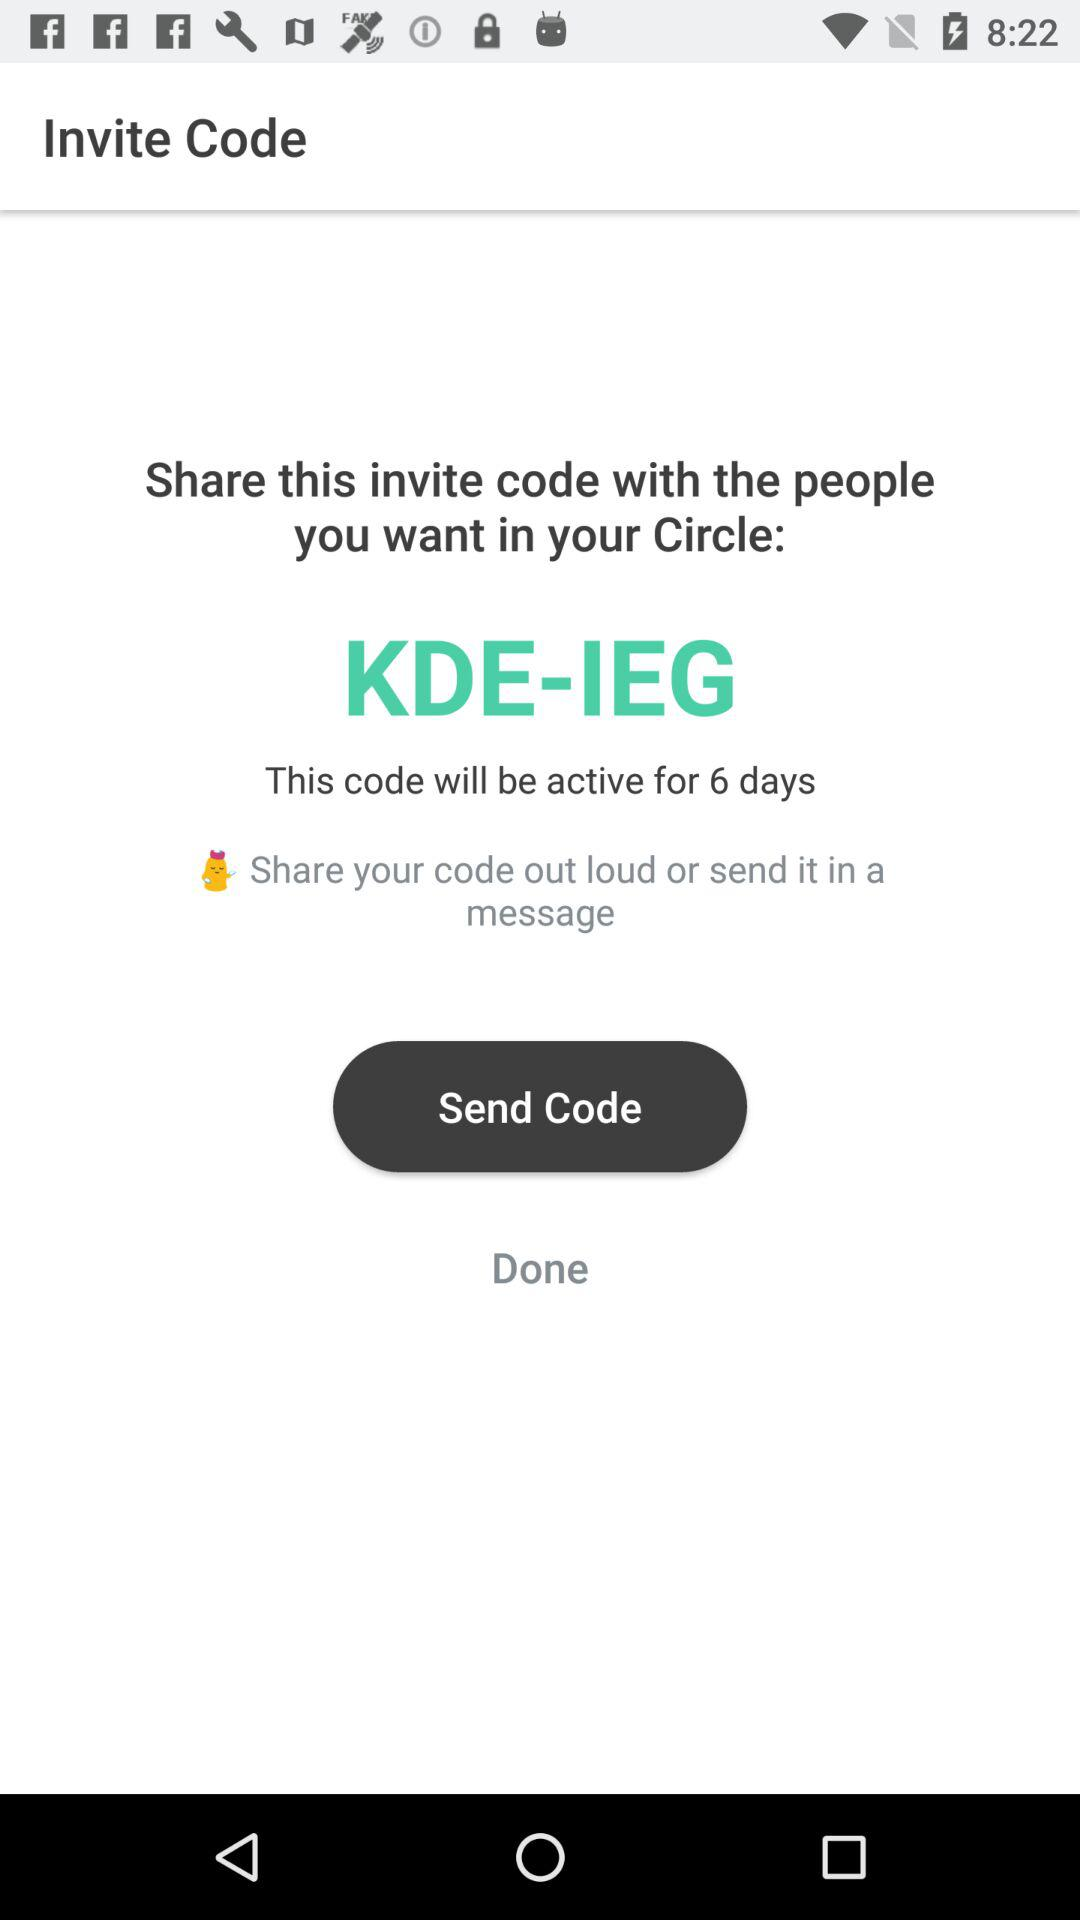Who can you share the code with in a message?
When the provided information is insufficient, respond with <no answer>. <no answer> 